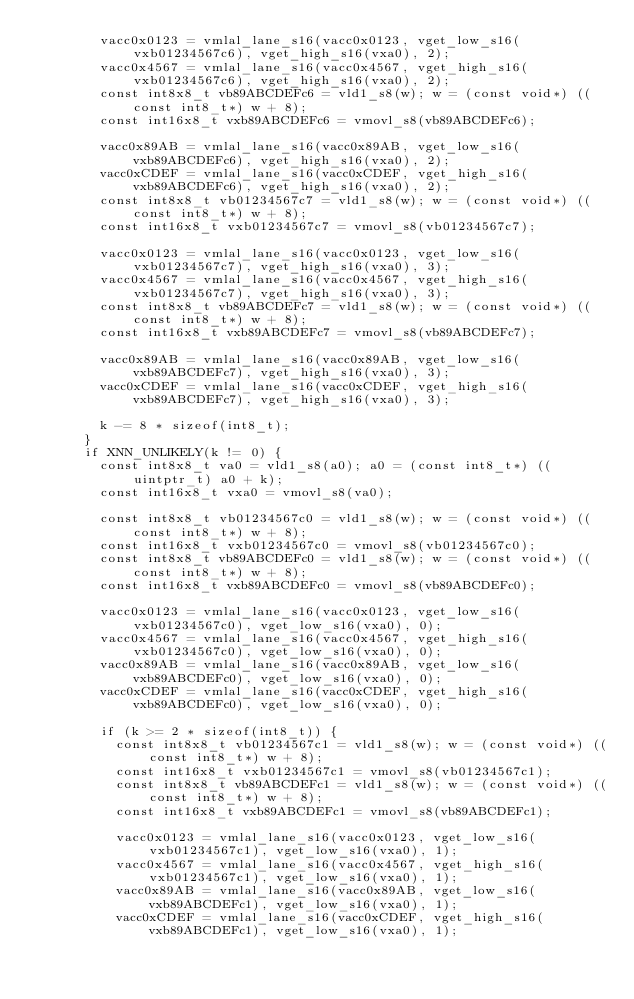<code> <loc_0><loc_0><loc_500><loc_500><_C_>        vacc0x0123 = vmlal_lane_s16(vacc0x0123, vget_low_s16(vxb01234567c6), vget_high_s16(vxa0), 2);
        vacc0x4567 = vmlal_lane_s16(vacc0x4567, vget_high_s16(vxb01234567c6), vget_high_s16(vxa0), 2);
        const int8x8_t vb89ABCDEFc6 = vld1_s8(w); w = (const void*) ((const int8_t*) w + 8);
        const int16x8_t vxb89ABCDEFc6 = vmovl_s8(vb89ABCDEFc6);

        vacc0x89AB = vmlal_lane_s16(vacc0x89AB, vget_low_s16(vxb89ABCDEFc6), vget_high_s16(vxa0), 2);
        vacc0xCDEF = vmlal_lane_s16(vacc0xCDEF, vget_high_s16(vxb89ABCDEFc6), vget_high_s16(vxa0), 2);
        const int8x8_t vb01234567c7 = vld1_s8(w); w = (const void*) ((const int8_t*) w + 8);
        const int16x8_t vxb01234567c7 = vmovl_s8(vb01234567c7);

        vacc0x0123 = vmlal_lane_s16(vacc0x0123, vget_low_s16(vxb01234567c7), vget_high_s16(vxa0), 3);
        vacc0x4567 = vmlal_lane_s16(vacc0x4567, vget_high_s16(vxb01234567c7), vget_high_s16(vxa0), 3);
        const int8x8_t vb89ABCDEFc7 = vld1_s8(w); w = (const void*) ((const int8_t*) w + 8);
        const int16x8_t vxb89ABCDEFc7 = vmovl_s8(vb89ABCDEFc7);

        vacc0x89AB = vmlal_lane_s16(vacc0x89AB, vget_low_s16(vxb89ABCDEFc7), vget_high_s16(vxa0), 3);
        vacc0xCDEF = vmlal_lane_s16(vacc0xCDEF, vget_high_s16(vxb89ABCDEFc7), vget_high_s16(vxa0), 3);

        k -= 8 * sizeof(int8_t);
      }
      if XNN_UNLIKELY(k != 0) {
        const int8x8_t va0 = vld1_s8(a0); a0 = (const int8_t*) ((uintptr_t) a0 + k);
        const int16x8_t vxa0 = vmovl_s8(va0);

        const int8x8_t vb01234567c0 = vld1_s8(w); w = (const void*) ((const int8_t*) w + 8);
        const int16x8_t vxb01234567c0 = vmovl_s8(vb01234567c0);
        const int8x8_t vb89ABCDEFc0 = vld1_s8(w); w = (const void*) ((const int8_t*) w + 8);
        const int16x8_t vxb89ABCDEFc0 = vmovl_s8(vb89ABCDEFc0);

        vacc0x0123 = vmlal_lane_s16(vacc0x0123, vget_low_s16(vxb01234567c0), vget_low_s16(vxa0), 0);
        vacc0x4567 = vmlal_lane_s16(vacc0x4567, vget_high_s16(vxb01234567c0), vget_low_s16(vxa0), 0);
        vacc0x89AB = vmlal_lane_s16(vacc0x89AB, vget_low_s16(vxb89ABCDEFc0), vget_low_s16(vxa0), 0);
        vacc0xCDEF = vmlal_lane_s16(vacc0xCDEF, vget_high_s16(vxb89ABCDEFc0), vget_low_s16(vxa0), 0);

        if (k >= 2 * sizeof(int8_t)) {
          const int8x8_t vb01234567c1 = vld1_s8(w); w = (const void*) ((const int8_t*) w + 8);
          const int16x8_t vxb01234567c1 = vmovl_s8(vb01234567c1);
          const int8x8_t vb89ABCDEFc1 = vld1_s8(w); w = (const void*) ((const int8_t*) w + 8);
          const int16x8_t vxb89ABCDEFc1 = vmovl_s8(vb89ABCDEFc1);

          vacc0x0123 = vmlal_lane_s16(vacc0x0123, vget_low_s16(vxb01234567c1), vget_low_s16(vxa0), 1);
          vacc0x4567 = vmlal_lane_s16(vacc0x4567, vget_high_s16(vxb01234567c1), vget_low_s16(vxa0), 1);
          vacc0x89AB = vmlal_lane_s16(vacc0x89AB, vget_low_s16(vxb89ABCDEFc1), vget_low_s16(vxa0), 1);
          vacc0xCDEF = vmlal_lane_s16(vacc0xCDEF, vget_high_s16(vxb89ABCDEFc1), vget_low_s16(vxa0), 1);
</code> 